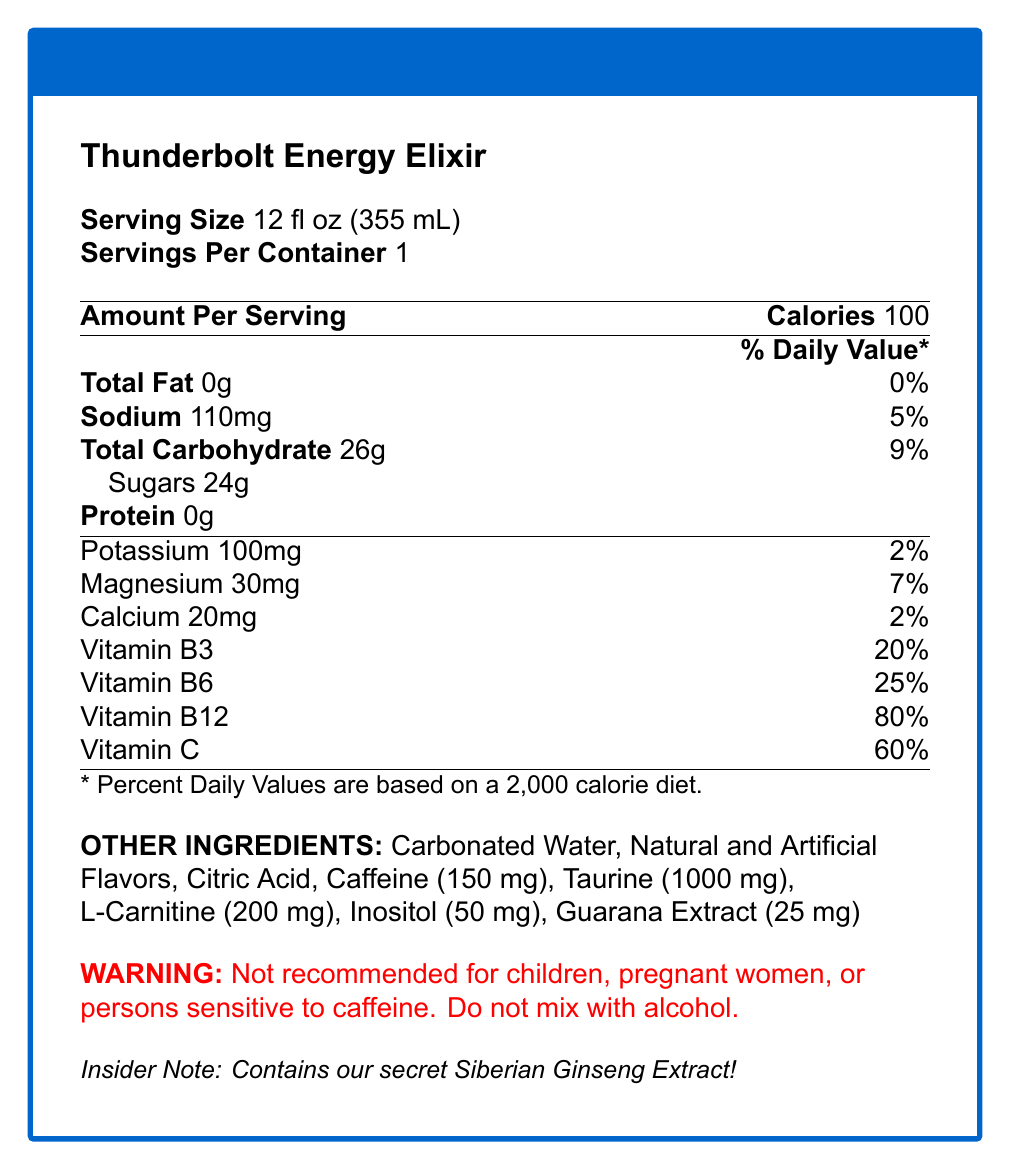what is the serving size for Thunderbolt Energy Elixir? The serving size is explicitly mentioned in the document as 12 fl oz (355 mL).
Answer: 12 fl oz (355 mL) How many calories are in one serving? The document specifies that one serving contains 100 calories.
Answer: 100 What is the secret ingredient in Thunderbolt Energy Elixir? The insider notes at the bottom of the document reveal that the secret ingredient is Siberian Ginseng Extract.
Answer: Siberian Ginseng Extract Name three vitamins present in Thunderbolt Energy Elixir and their % Daily Value. The document lists the vitamins along with their % Daily Value.
Answer: Vitamin B3 (20% DV), Vitamin B6 (25% DV), Vitamin C (60% DV) How much caffeine is in one serving of Thunderbolt Energy Elixir? In the section listing other ingredients, caffeine content is mentioned as 150 mg.
Answer: 150 mg What is the primary flavor profile of Thunderbolt Energy Elixir? The insider notes mention that the flavor profile is Citrus-Berry Fusion.
Answer: Citrus-Berry Fusion Which of the following electrolytes is NOT listed in Thunderbolt Energy Elixir? A. Potassium B. Sodium C. Chloride D. Magnesium The document lists Potassium, Sodium, and Magnesium as electrolytes but does not mention Chloride.
Answer: C. Chloride What is the main warning associated with consuming Thunderbolt Energy Elixir? A. Not recommended for children B. Do not mix with alcohol C. Both A and B are correct D. No specific warning The document's warning explicitly mentions both avoiding consumption by children and not mixing with alcohol.
Answer: C. Both A and B are correct Is Thunderbolt Energy Elixir recommended for pregnant women? The document clearly states that it is not recommended for pregnant women as part of the warning.
Answer: No Summarize the main idea of the document. The document serves as a comprehensive guide to understanding what Thunderbolt Energy Elixir contains and its benefits, as well as safety precautions and insider insights.
Answer: The document provides detailed information about Thunderbolt Energy Elixir, including nutritional facts, vitamins, electrolytes, other ingredients, and a warning. It also highlights an insider note about the secret ingredient and flavor profile, with a backstory about the product's development. How many grams of sugars are present in one serving? The document lists the sugar content as 24 grams.
Answer: 24 grams What are the benefits of Inositol in Thunderbolt Energy Elixir? The document does not provide information on the benefits of Inositol.
Answer: Cannot be determined How much taurine is in one serving of the drink? The taurine content is listed in the other ingredients section as 1000 mg.
Answer: 1000 mg What feedback did players give about Thunderbolt Energy Elixir? The insider notes mention that players swore by the drink and felt it helped with their game performance.
Answer: They claimed it helped them maintain peak performance throughout the game. What % Daily Value of Vitamin B12 does Thunderbolt Energy Elixir provide? The document specifies that the drink provides 80% of the Daily Value for Vitamin B12.
Answer: 80% DV What is NOT true about Thunderbolt Energy Elixir? A. Contains Vitamin C B. Has zero protein C. Includes Aspartame D. Contains Caffeine The document does not mention Aspartame as an ingredient, but lists Caffeine, Vitamins, and that it has zero protein.
Answer: C. Includes Aspartame What was the reason behind the development of Thunderbolt Energy Elixir according to the insider notes? The insider notes explain that Alvin and the respondent spent nights in the lab developing the formula to help maintain performance in challenging moments.
Answer: To give an edge during grueling fourth-quarter moments. 